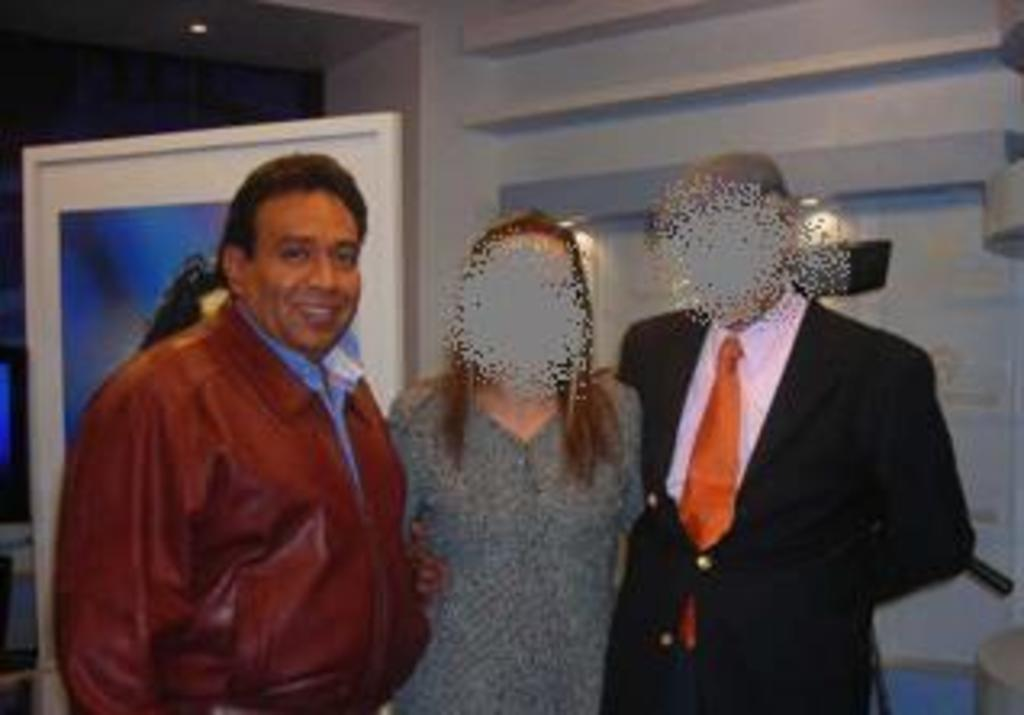How many people are in the image? There are three persons in the image. What are the persons doing in the image? The persons are standing. What can be seen in the background of the image? There is a wall and a board in the background of the image, along with other objects. How many cows are visible in the wilderness behind the persons in the image? There are no cows or wilderness present in the image; it features three standing persons in front of a wall and a board with other objects in the background. 